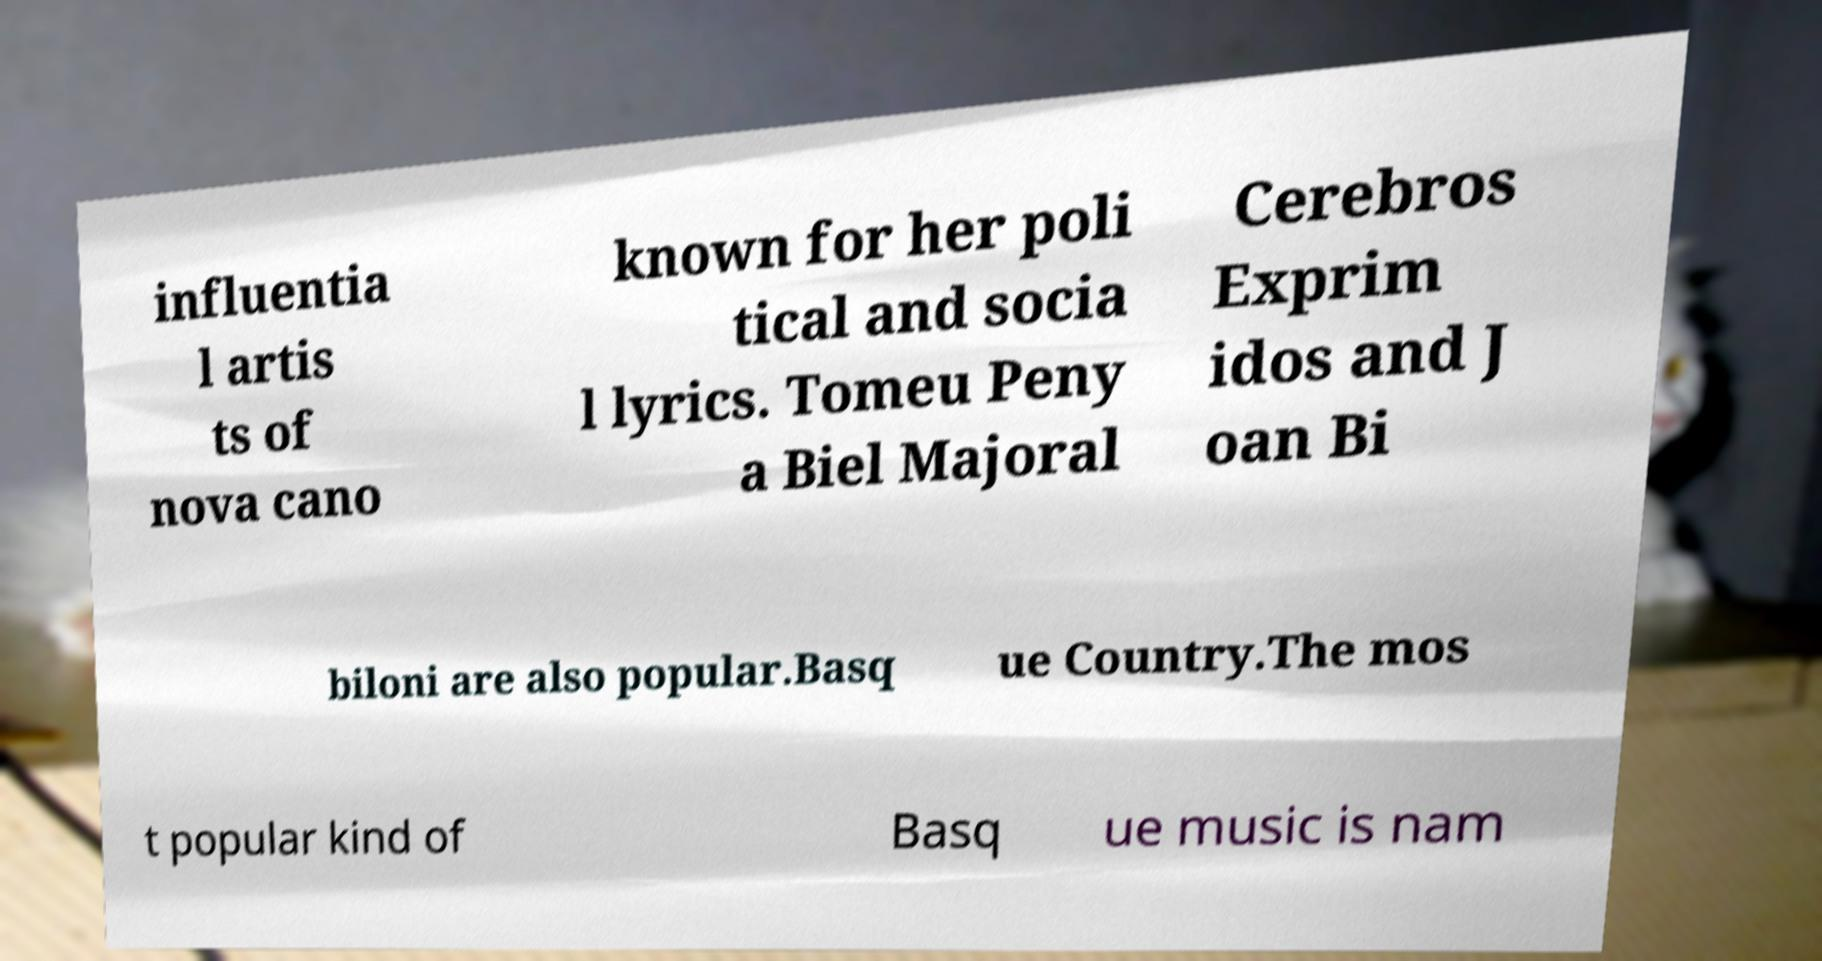For documentation purposes, I need the text within this image transcribed. Could you provide that? influentia l artis ts of nova cano known for her poli tical and socia l lyrics. Tomeu Peny a Biel Majoral Cerebros Exprim idos and J oan Bi biloni are also popular.Basq ue Country.The mos t popular kind of Basq ue music is nam 